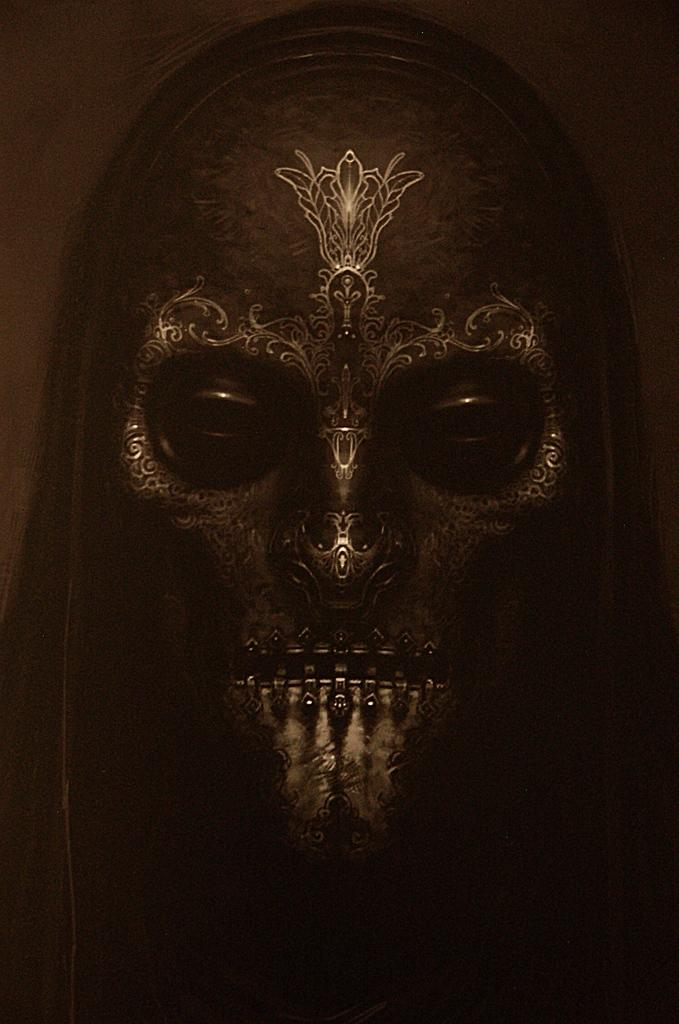What object can be seen in the image? There is a mask in the image. What can be observed about the mask's appearance? The mask has a design on it. What type of prison is depicted in the image? There is no prison present in the image; it features a mask with a design on it. What organization is responsible for the juice in the image? There is no juice or organization mentioned in the image, as it only contains a mask with a design on it. 